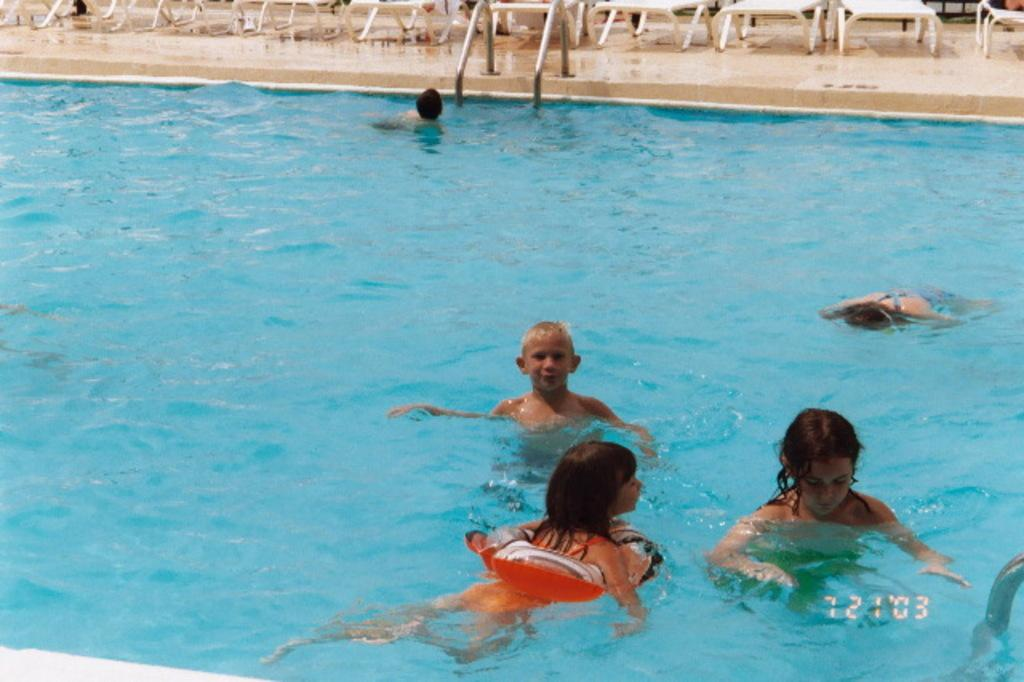What activity are the kids engaged in within the image? The kids are in a swimming pool in the image. What objects can be seen at the top of the image? There are tables visible at the top of the image. Reasoning: Let's think step by identifying the main subjects and objects in the image based on the provided facts. We then formulate questions that focus on the activity and objects present in the image, ensuring that each question can be answered definitively with the information given. We avoid yes/no questions and ensure that the language is simple and clear. Absurd Question/Answer: How many apples are on the chair in the image? There is no chair or apples present in the image. What is the health status of the kids in the image? The health status of the kids cannot be determined from the image alone. 